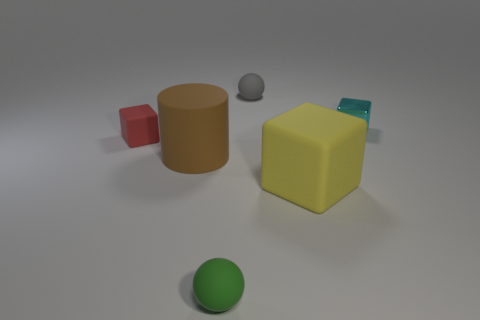Add 3 tiny cyan matte cubes. How many objects exist? 9 Subtract all balls. How many objects are left? 4 Add 4 gray spheres. How many gray spheres exist? 5 Subtract 0 yellow cylinders. How many objects are left? 6 Subtract all brown rubber objects. Subtract all red cubes. How many objects are left? 4 Add 2 small cyan cubes. How many small cyan cubes are left? 3 